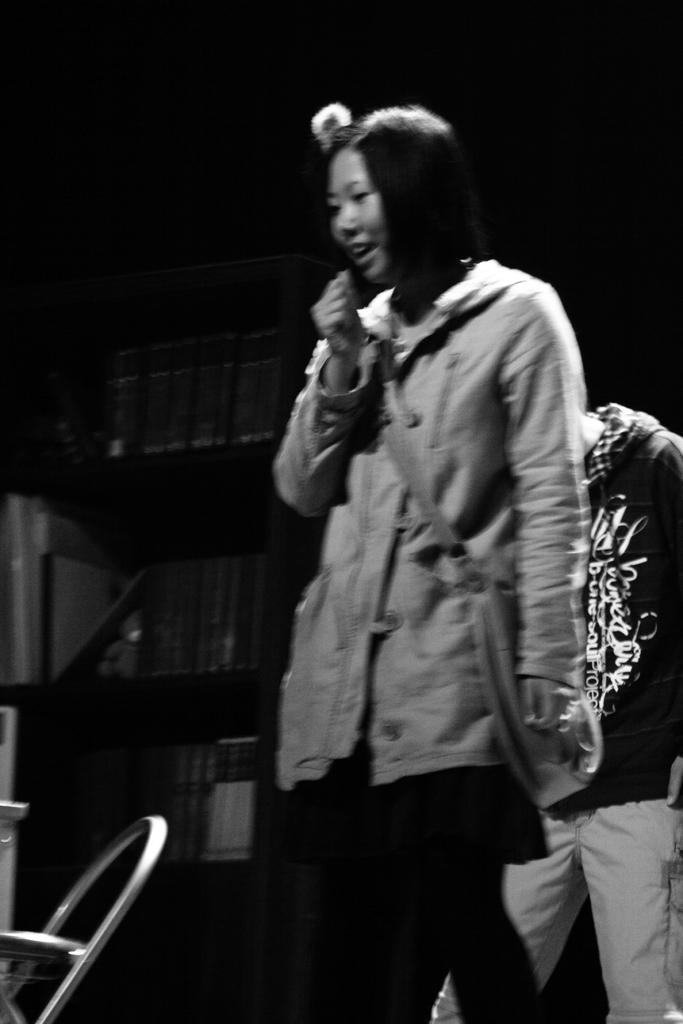What is the color scheme of the image? The image is black and white. How many people are in the image? There are two persons standing in the image. What piece of furniture is present in the image? There is a chair in the image. What can be seen in the background of the image? The background of the image is dark. Can you describe any other objects in the image besides the chair? Yes, there are other objects in the image. What type of wood is the pen made of in the image? There is no pen present in the image, so it is not possible to determine what type of wood it might be made of. 